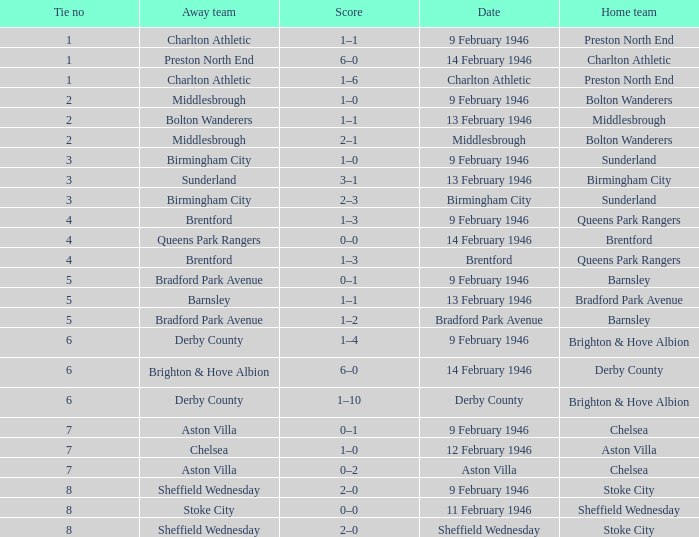What was the Tie no when then home team was Stoke City for the game played on 9 February 1946? 8.0. 